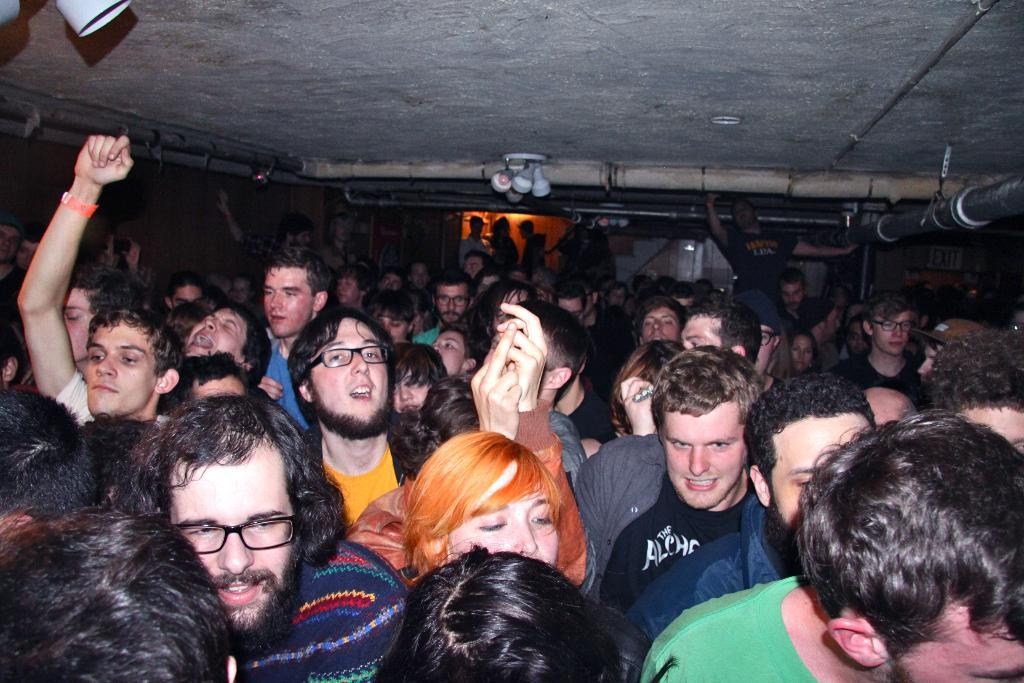What can be seen in the image? There are people standing in the image. What is on top of the people in the image? There are lights on top in the image. What type of structure can be seen in the image? There are iron poles in the image. Where is the crib located in the image? There is no crib present in the image. What type of food is being served in the lunchroom in the image? There is no lunchroom present in the image. 